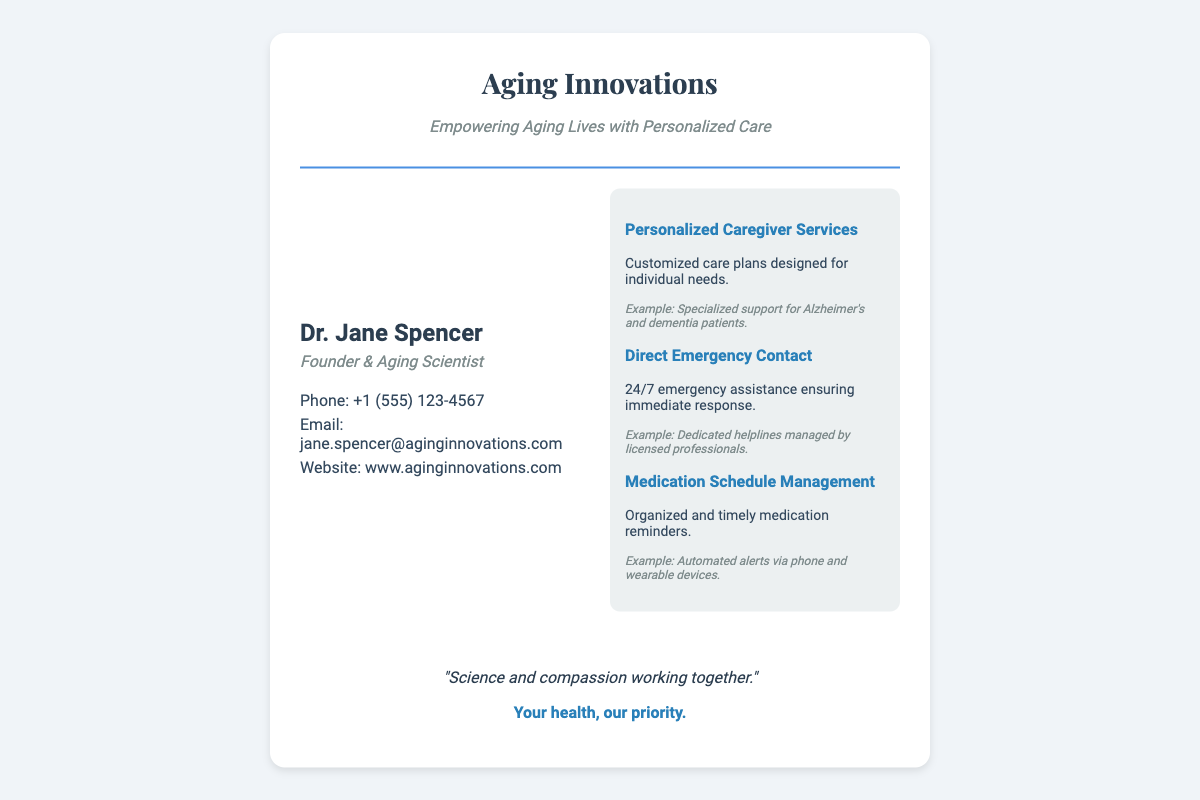what is the name of the founder? The founder's name is listed in the personal details section of the business card.
Answer: Dr. Jane Spencer what is the company's slogan? The slogan is prominently displayed in the additional info section you can see the focus on health and priorities.
Answer: Your health, our priority what is the contact phone number? The contact phone number is specified in the contact info section of the document.
Answer: +1 (555) 123-4567 what service provides 24/7 assistance? The service that ensures immediate response is also mentioned in the services section of the card.
Answer: Direct Emergency Contact how many services are listed? The number of services can be counted in the services section of the business card.
Answer: 3 what type of support is specialized for Alzheimer's? The example given under personalized caregiver services highlights a specific type of support.
Answer: Specialized support for Alzheimer's who is the title holder of 'Founder & Aging Scientist'? The title holder is specified in the personal details section of the document, knowing it is linked to the founder.
Answer: Dr. Jane Spencer which service involves medication reminders? This service is explicitly mentioned in the services section, highlighting its purpose.
Answer: Medication Schedule Management 